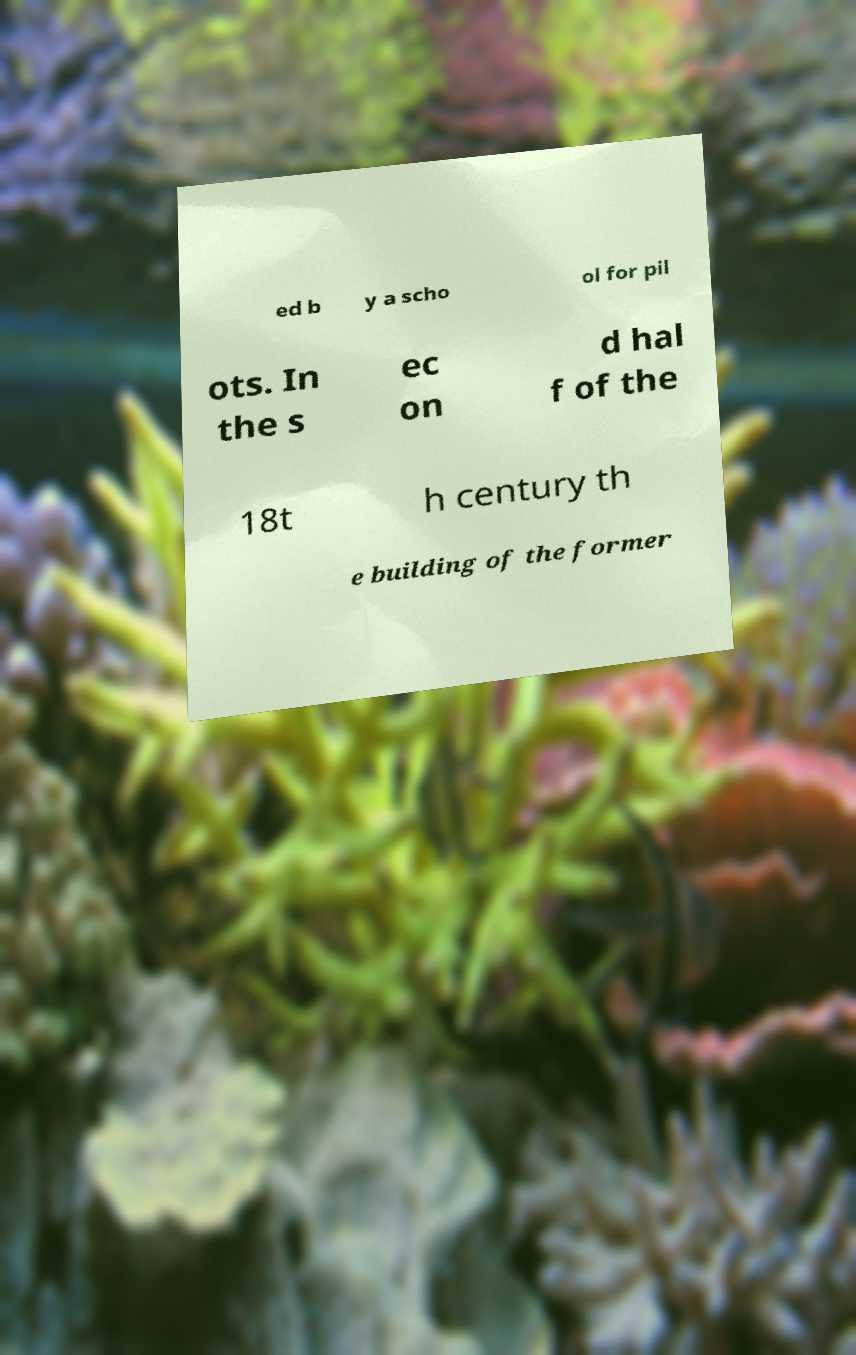Could you extract and type out the text from this image? ed b y a scho ol for pil ots. In the s ec on d hal f of the 18t h century th e building of the former 